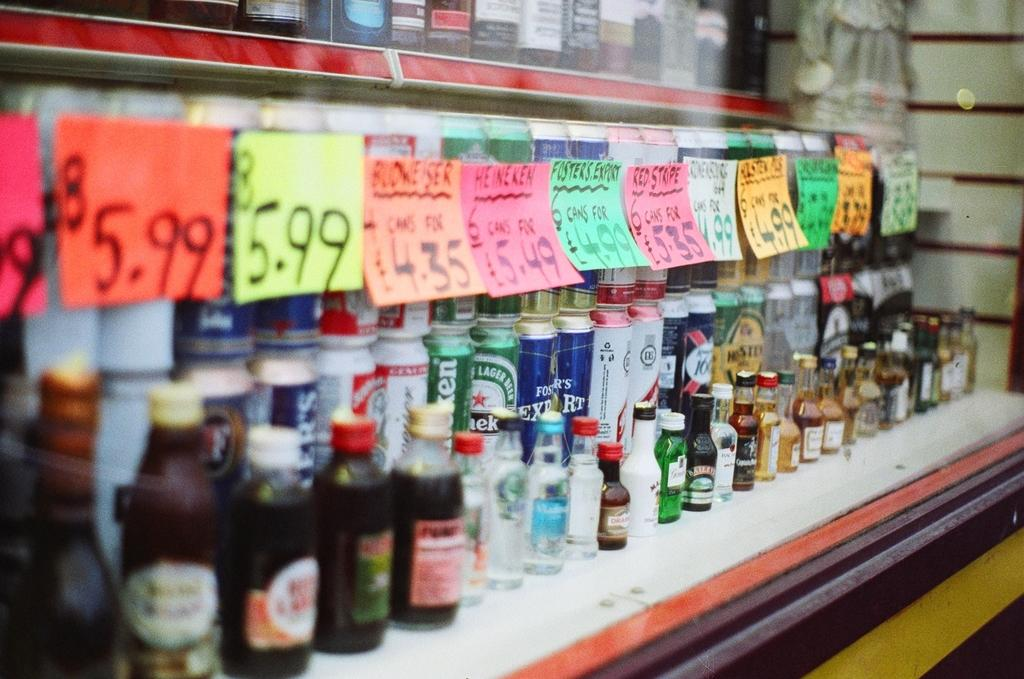Provide a one-sentence caption for the provided image. Green Heineken can under a pink sign that says $5.49. 